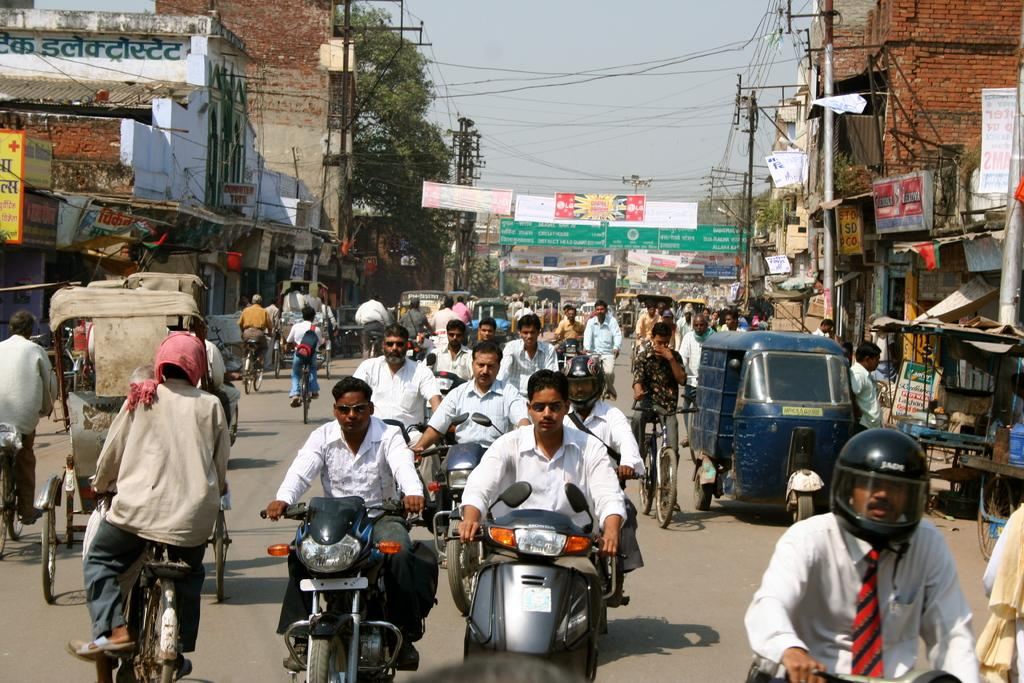What is happening in the image involving people? There is a group of people in the image, and some of them are riding bicycles, motorbikes, and rickshaws. What types of vehicles can be seen in the image? Bicycles, motorbikes, and rickshaws are visible in the image. What structures are present in the image? There are buildings, poles, and banners in the image. What type of natural elements can be seen in the image? Trees are visible in the image. What else can be seen in the image? There are wires and the sky is visible in the background of the image. How many fans are visible in the image? There are no fans present in the image. What type of smile can be seen on the trees in the image? Trees do not have the ability to smile, and there are no faces or expressions depicted on them in the image. 